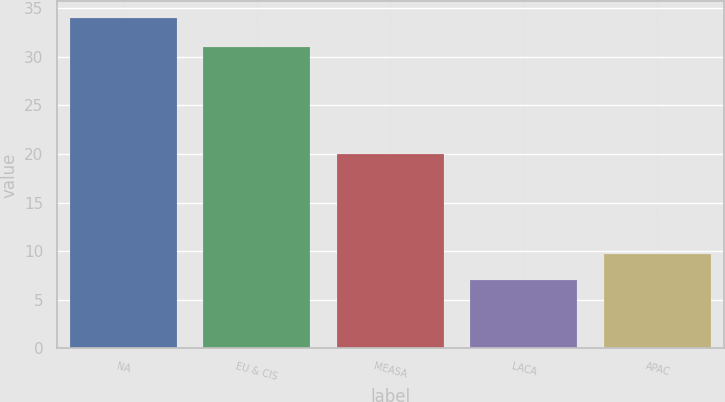<chart> <loc_0><loc_0><loc_500><loc_500><bar_chart><fcel>NA<fcel>EU & CIS<fcel>MEASA<fcel>LACA<fcel>APAC<nl><fcel>34<fcel>31<fcel>20<fcel>7<fcel>9.7<nl></chart> 